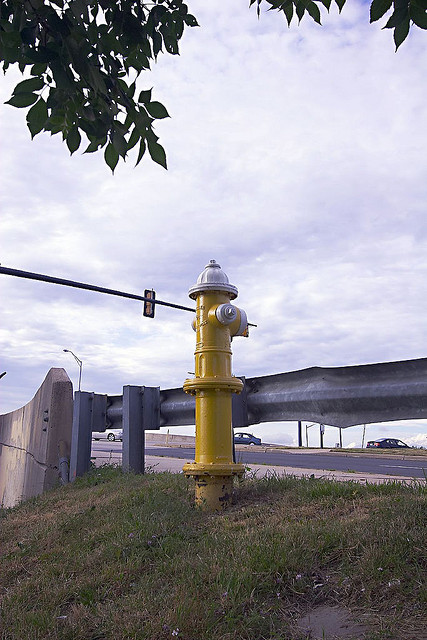<image>How tall is the fire hydrant? I don't know how tall the fire hydrant is. It can be 3 feet or 4 feet. Has the safety railing ever been damaged? I don't know if the safety railing has ever been damaged. It might have been in an accident. How tall is the fire hydrant? It is unknown how tall the fire hydrant is. It can be seen as 3 ft, 4 ft or very tall. Has the safety railing ever been damaged? I don't know if the safety railing has ever been damaged. It seems that it has been damaged at some point. 